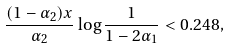Convert formula to latex. <formula><loc_0><loc_0><loc_500><loc_500>\frac { ( 1 - \alpha _ { 2 } ) x } { \alpha _ { 2 } } \log \frac { 1 } { 1 - 2 \alpha _ { 1 } } < 0 . 2 4 8 ,</formula> 